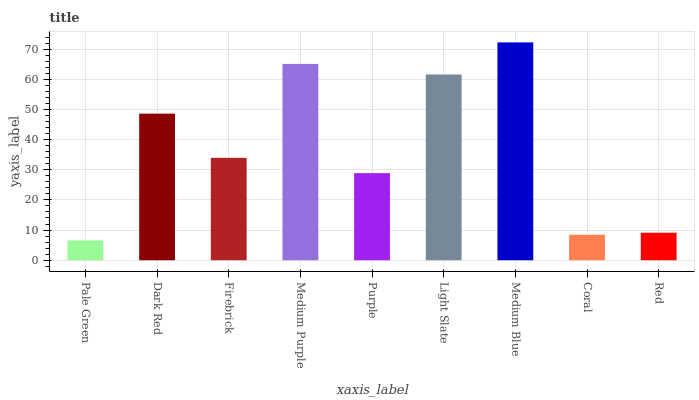Is Medium Blue the maximum?
Answer yes or no. Yes. Is Dark Red the minimum?
Answer yes or no. No. Is Dark Red the maximum?
Answer yes or no. No. Is Dark Red greater than Pale Green?
Answer yes or no. Yes. Is Pale Green less than Dark Red?
Answer yes or no. Yes. Is Pale Green greater than Dark Red?
Answer yes or no. No. Is Dark Red less than Pale Green?
Answer yes or no. No. Is Firebrick the high median?
Answer yes or no. Yes. Is Firebrick the low median?
Answer yes or no. Yes. Is Medium Purple the high median?
Answer yes or no. No. Is Pale Green the low median?
Answer yes or no. No. 